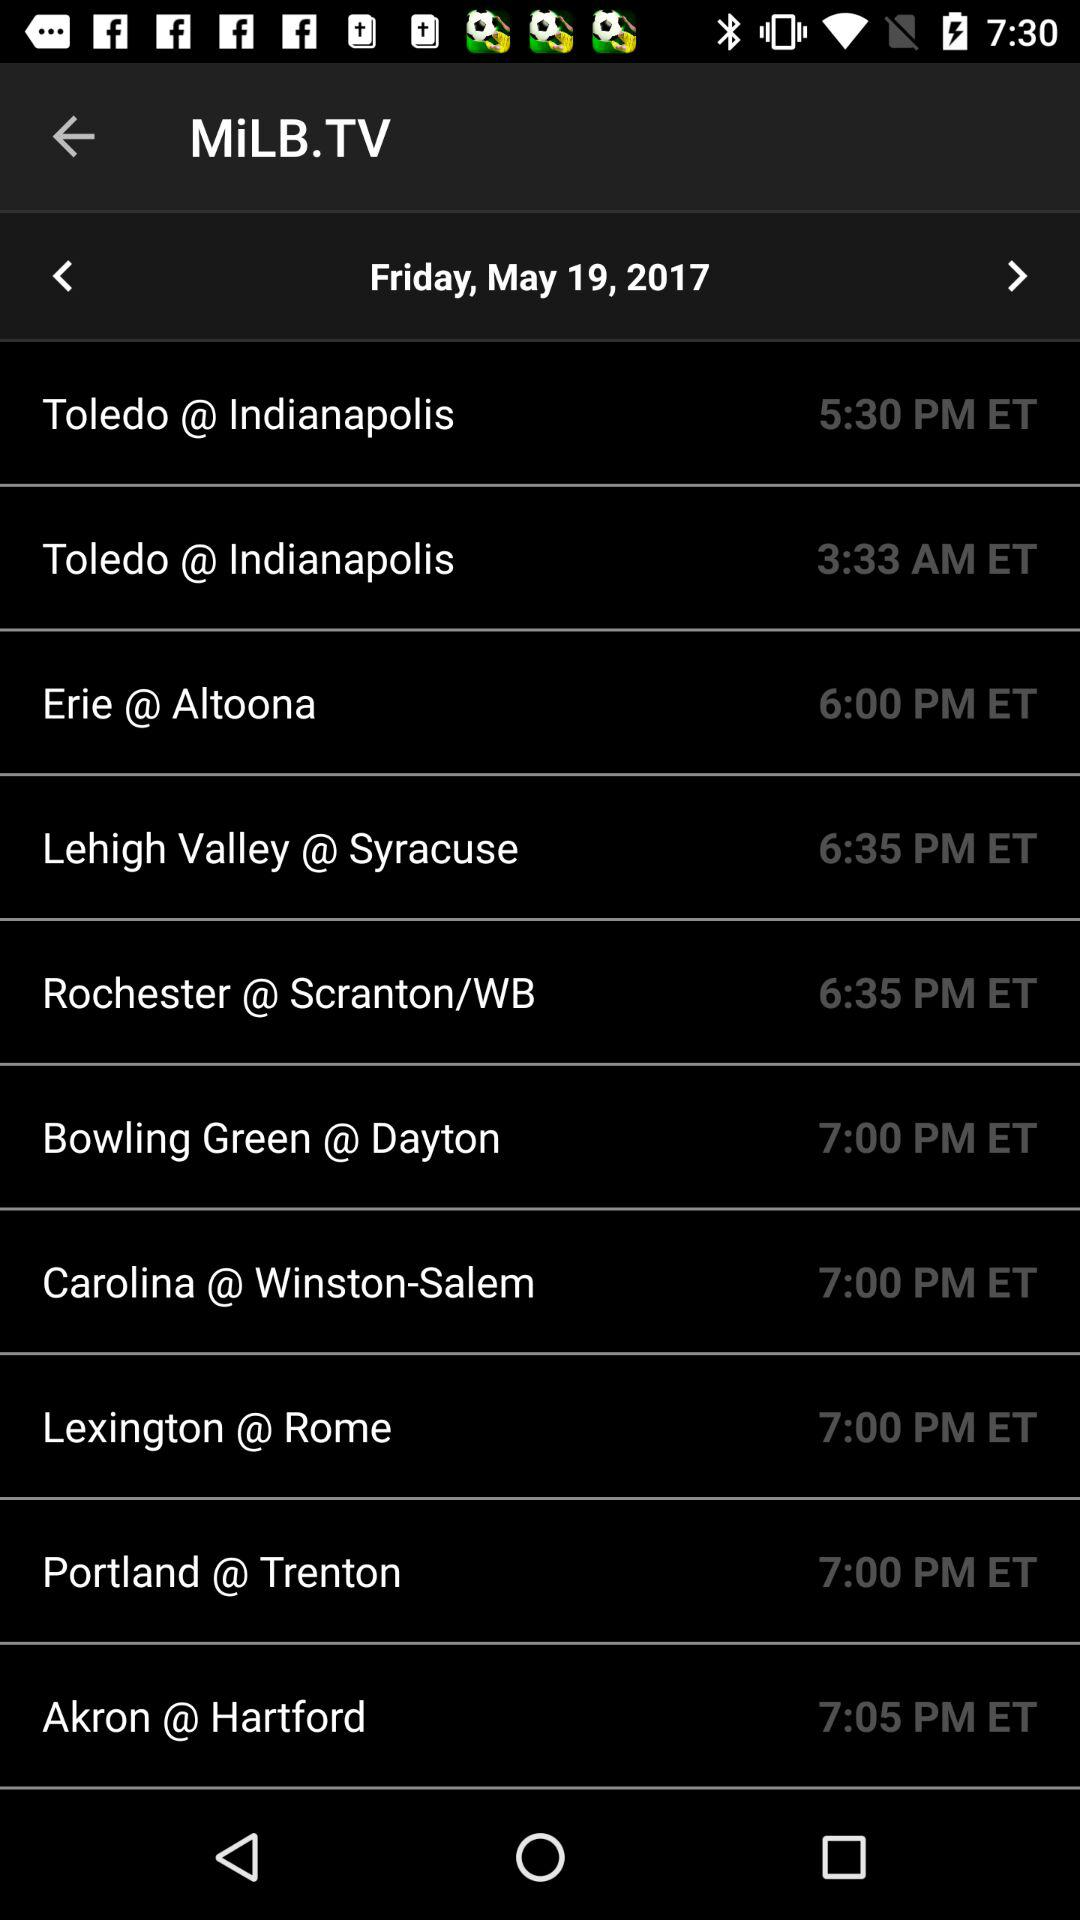How many games are on Saturday?
When the provided information is insufficient, respond with <no answer>. <no answer> 